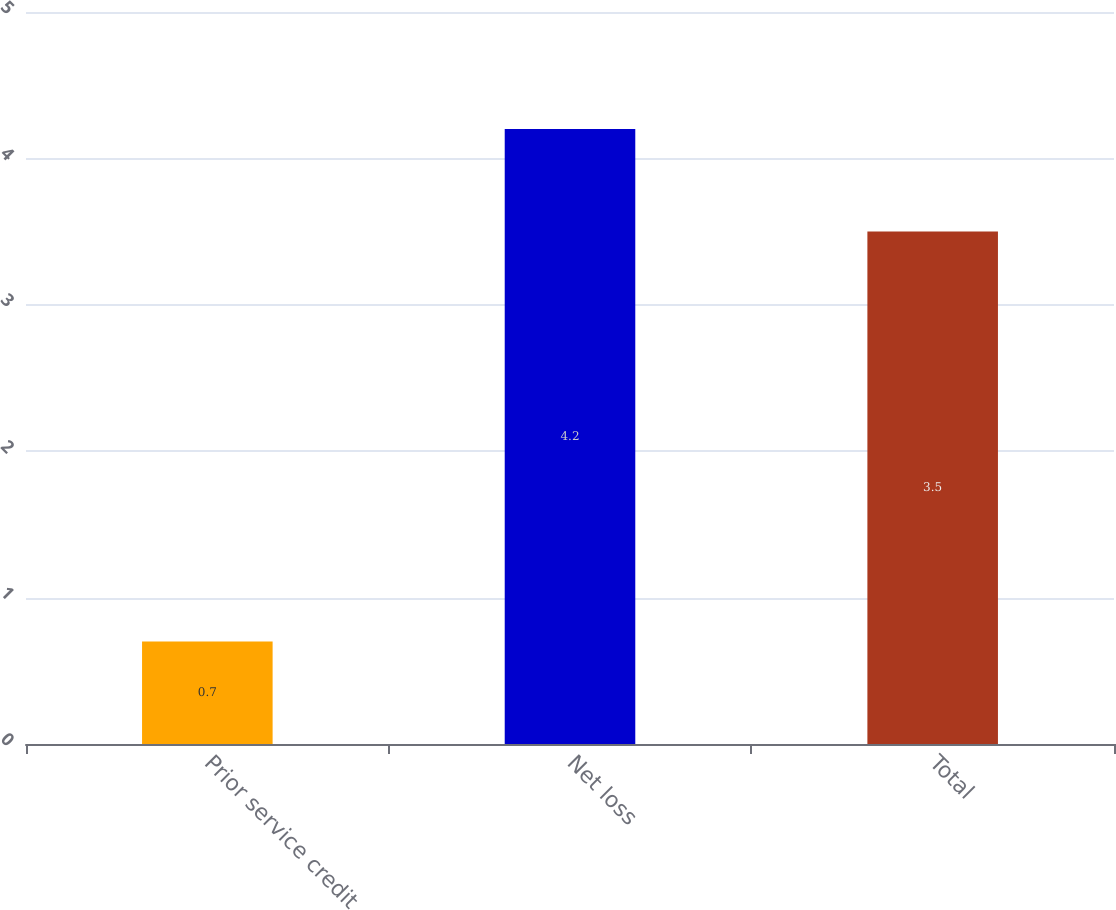Convert chart. <chart><loc_0><loc_0><loc_500><loc_500><bar_chart><fcel>Prior service credit<fcel>Net loss<fcel>Total<nl><fcel>0.7<fcel>4.2<fcel>3.5<nl></chart> 